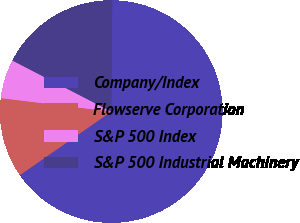<chart> <loc_0><loc_0><loc_500><loc_500><pie_chart><fcel>Company/Index<fcel>Flowserve Corporation<fcel>S&P 500 Index<fcel>S&P 500 Industrial Machinery<nl><fcel>65.19%<fcel>11.6%<fcel>5.65%<fcel>17.56%<nl></chart> 